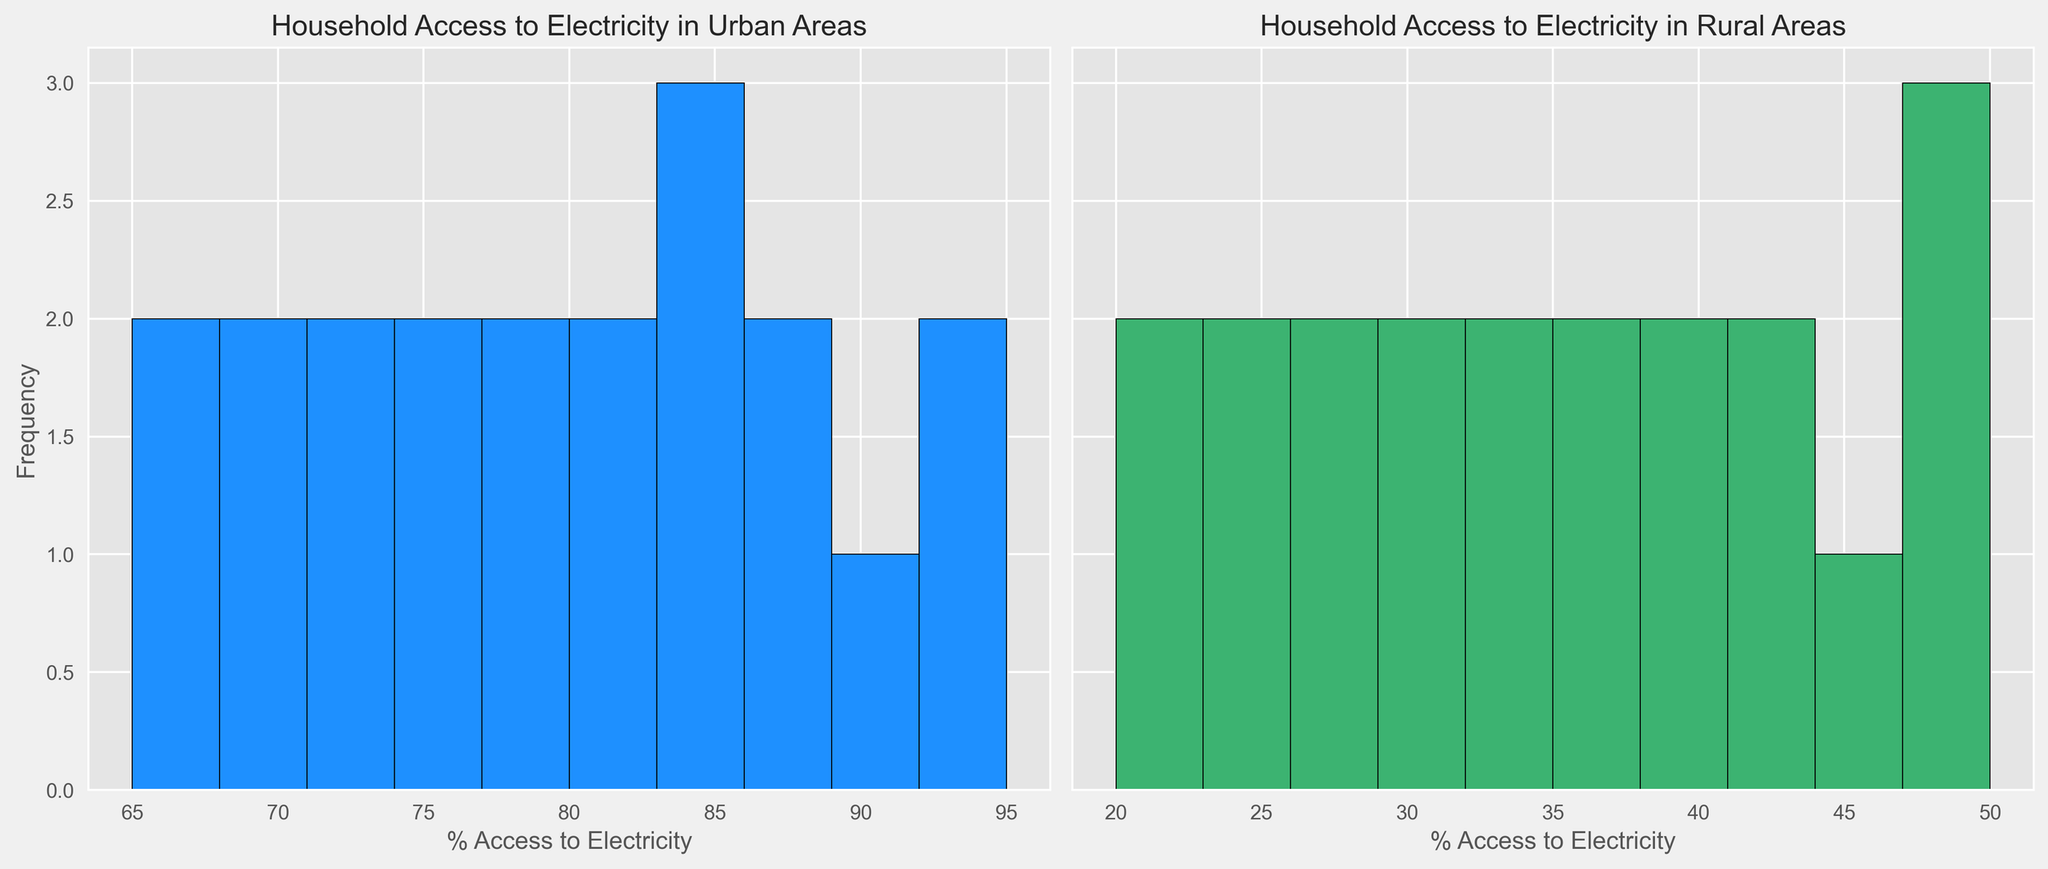What is the general trend of household access to electricity in urban areas compared to rural areas? The histogram shows that the urban areas have a higher percentage of household access to electricity, with most values clustering between 65% and 95%. In contrast, rural areas have a lower percentage, with most values clustering between 20% and 50%.
Answer: Urban areas have higher access What is the highest frequency range of household access to electricity in urban areas? The highest frequency range in urban areas is between 70% and 80%, as the histogram bins in this range have the tallest bars.
Answer: 70%-80% Which has more variability in household access to electricity, urban or rural areas? To determine variability, we can observe the spread of the bars. Urban areas have a narrower spread (65% to 95%), while rural areas have a broader spread (20% to 50%), indicating greater variability in rural areas.
Answer: Rural areas What is the difference in the maximum access to electricity between urban and rural areas? The maximum access in urban areas is approximately 95%, while in rural areas it is around 50%. The difference is calculated as 95% - 50% = 45%.
Answer: 45% How does the frequency of household access between 40% and 50% in rural areas compare to any access level in urban areas? In rural areas, the frequency of access between 40% and 50% is relatively higher, with several bars in that range, while urban areas generally do not have bars in this low range, indicating higher access overall in urban areas.
Answer: Higher in rural for 40%-50%, lower for urban in any range In which area is there a higher frequency of households with 80%-90% access to electricity? The urban histogram has bars within the 80%-90% access range, while the rural histogram has no bars in this range, indicating a higher frequency in urban areas.
Answer: Urban areas What is the median household access to electricity in rural areas, and how do you determine it visually? To find the median, look for the middle value in the spread. For rural areas, visually, the central clustered bars suggest the median is around 35%.
Answer: 35% What is the average household access to electricity in urban areas, based on the visual data? An average can be estimated by considering the central tendency of the histogram. Most values in urban areas cluster around 80%, so the average access is approximately 80%.
Answer: 80% How many distinct ranges of household access to electricity exist in urban areas? By observing the histogram, there are about 10 distinct bins, each representing a range.
Answer: 10 If you were to prioritize infrastructure improvement, which area appears to need more focus based on the histogram? The rural areas, as they have lower overall access to electricity between 20% and 50%, indicating a need for more infrastructure investment.
Answer: Rural areas 